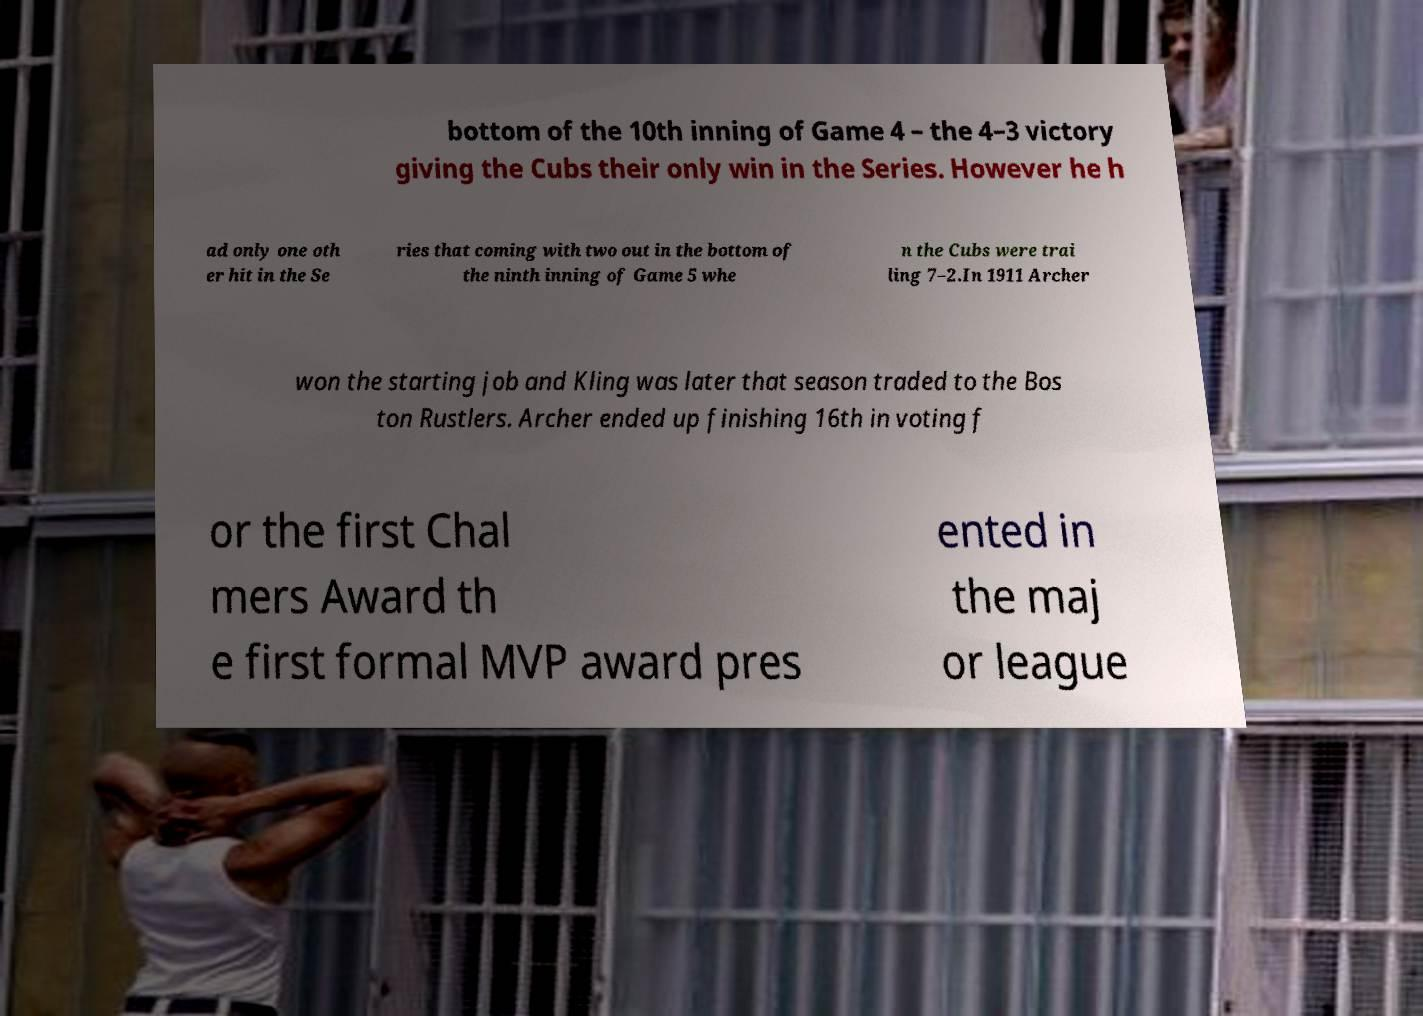I need the written content from this picture converted into text. Can you do that? bottom of the 10th inning of Game 4 – the 4–3 victory giving the Cubs their only win in the Series. However he h ad only one oth er hit in the Se ries that coming with two out in the bottom of the ninth inning of Game 5 whe n the Cubs were trai ling 7–2.In 1911 Archer won the starting job and Kling was later that season traded to the Bos ton Rustlers. Archer ended up finishing 16th in voting f or the first Chal mers Award th e first formal MVP award pres ented in the maj or league 